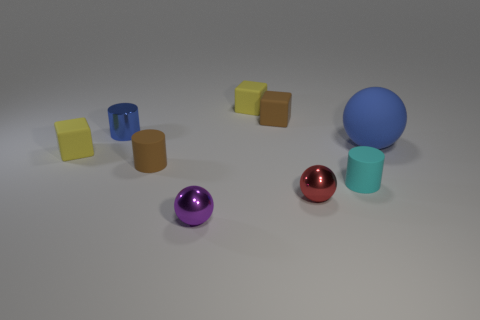Subtract all spheres. How many objects are left? 6 Add 9 tiny cyan things. How many tiny cyan things are left? 10 Add 8 big matte balls. How many big matte balls exist? 9 Subtract 0 gray balls. How many objects are left? 9 Subtract all tiny gray rubber objects. Subtract all red spheres. How many objects are left? 8 